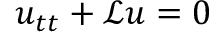Convert formula to latex. <formula><loc_0><loc_0><loc_500><loc_500>u _ { t t } + \ m a t h s c r { L } u = 0</formula> 